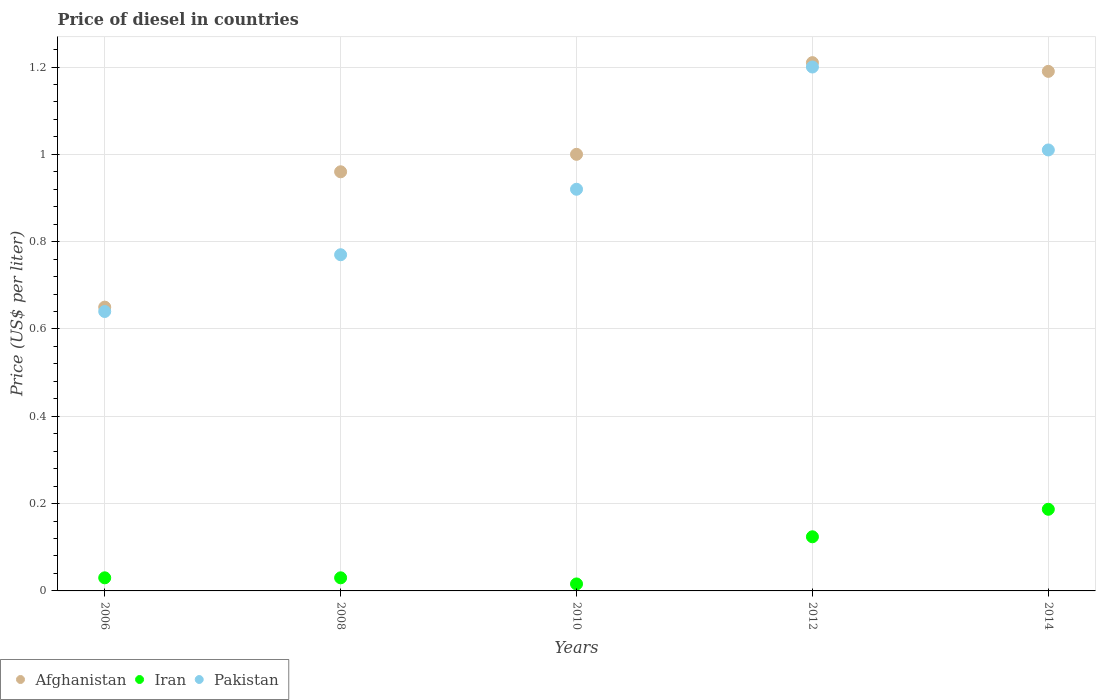How many different coloured dotlines are there?
Provide a short and direct response. 3. Is the number of dotlines equal to the number of legend labels?
Keep it short and to the point. Yes. What is the price of diesel in Afghanistan in 2010?
Make the answer very short. 1. Across all years, what is the maximum price of diesel in Afghanistan?
Offer a terse response. 1.21. Across all years, what is the minimum price of diesel in Iran?
Provide a short and direct response. 0.02. In which year was the price of diesel in Iran minimum?
Provide a succinct answer. 2010. What is the total price of diesel in Afghanistan in the graph?
Your answer should be very brief. 5.01. What is the difference between the price of diesel in Pakistan in 2006 and that in 2012?
Your answer should be compact. -0.56. What is the difference between the price of diesel in Afghanistan in 2008 and the price of diesel in Pakistan in 2012?
Offer a very short reply. -0.24. What is the average price of diesel in Iran per year?
Give a very brief answer. 0.08. In the year 2006, what is the difference between the price of diesel in Afghanistan and price of diesel in Iran?
Your response must be concise. 0.62. In how many years, is the price of diesel in Iran greater than 0.32 US$?
Ensure brevity in your answer.  0. What is the ratio of the price of diesel in Iran in 2006 to that in 2014?
Offer a very short reply. 0.16. Is the price of diesel in Pakistan in 2006 less than that in 2008?
Offer a terse response. Yes. Is the difference between the price of diesel in Afghanistan in 2006 and 2010 greater than the difference between the price of diesel in Iran in 2006 and 2010?
Offer a terse response. No. What is the difference between the highest and the second highest price of diesel in Iran?
Provide a short and direct response. 0.06. What is the difference between the highest and the lowest price of diesel in Pakistan?
Ensure brevity in your answer.  0.56. Is the sum of the price of diesel in Pakistan in 2010 and 2012 greater than the maximum price of diesel in Iran across all years?
Offer a terse response. Yes. Does the price of diesel in Pakistan monotonically increase over the years?
Keep it short and to the point. No. How many dotlines are there?
Keep it short and to the point. 3. How many years are there in the graph?
Your answer should be very brief. 5. What is the difference between two consecutive major ticks on the Y-axis?
Offer a terse response. 0.2. Are the values on the major ticks of Y-axis written in scientific E-notation?
Your answer should be very brief. No. Does the graph contain any zero values?
Give a very brief answer. No. How are the legend labels stacked?
Keep it short and to the point. Horizontal. What is the title of the graph?
Offer a very short reply. Price of diesel in countries. Does "Guinea" appear as one of the legend labels in the graph?
Keep it short and to the point. No. What is the label or title of the Y-axis?
Offer a terse response. Price (US$ per liter). What is the Price (US$ per liter) of Afghanistan in 2006?
Your response must be concise. 0.65. What is the Price (US$ per liter) of Pakistan in 2006?
Your answer should be compact. 0.64. What is the Price (US$ per liter) of Pakistan in 2008?
Provide a succinct answer. 0.77. What is the Price (US$ per liter) in Afghanistan in 2010?
Ensure brevity in your answer.  1. What is the Price (US$ per liter) of Iran in 2010?
Provide a short and direct response. 0.02. What is the Price (US$ per liter) in Pakistan in 2010?
Your answer should be compact. 0.92. What is the Price (US$ per liter) in Afghanistan in 2012?
Offer a very short reply. 1.21. What is the Price (US$ per liter) in Iran in 2012?
Offer a very short reply. 0.12. What is the Price (US$ per liter) in Pakistan in 2012?
Give a very brief answer. 1.2. What is the Price (US$ per liter) of Afghanistan in 2014?
Offer a terse response. 1.19. What is the Price (US$ per liter) of Iran in 2014?
Provide a short and direct response. 0.19. Across all years, what is the maximum Price (US$ per liter) in Afghanistan?
Keep it short and to the point. 1.21. Across all years, what is the maximum Price (US$ per liter) in Iran?
Offer a very short reply. 0.19. Across all years, what is the minimum Price (US$ per liter) in Afghanistan?
Provide a succinct answer. 0.65. Across all years, what is the minimum Price (US$ per liter) of Iran?
Keep it short and to the point. 0.02. Across all years, what is the minimum Price (US$ per liter) of Pakistan?
Your answer should be very brief. 0.64. What is the total Price (US$ per liter) in Afghanistan in the graph?
Your answer should be compact. 5.01. What is the total Price (US$ per liter) of Iran in the graph?
Provide a succinct answer. 0.39. What is the total Price (US$ per liter) of Pakistan in the graph?
Your answer should be compact. 4.54. What is the difference between the Price (US$ per liter) of Afghanistan in 2006 and that in 2008?
Provide a short and direct response. -0.31. What is the difference between the Price (US$ per liter) of Pakistan in 2006 and that in 2008?
Your answer should be very brief. -0.13. What is the difference between the Price (US$ per liter) in Afghanistan in 2006 and that in 2010?
Provide a short and direct response. -0.35. What is the difference between the Price (US$ per liter) of Iran in 2006 and that in 2010?
Keep it short and to the point. 0.01. What is the difference between the Price (US$ per liter) in Pakistan in 2006 and that in 2010?
Keep it short and to the point. -0.28. What is the difference between the Price (US$ per liter) of Afghanistan in 2006 and that in 2012?
Offer a terse response. -0.56. What is the difference between the Price (US$ per liter) in Iran in 2006 and that in 2012?
Provide a succinct answer. -0.09. What is the difference between the Price (US$ per liter) of Pakistan in 2006 and that in 2012?
Offer a terse response. -0.56. What is the difference between the Price (US$ per liter) in Afghanistan in 2006 and that in 2014?
Make the answer very short. -0.54. What is the difference between the Price (US$ per liter) in Iran in 2006 and that in 2014?
Provide a succinct answer. -0.16. What is the difference between the Price (US$ per liter) in Pakistan in 2006 and that in 2014?
Offer a very short reply. -0.37. What is the difference between the Price (US$ per liter) of Afghanistan in 2008 and that in 2010?
Offer a very short reply. -0.04. What is the difference between the Price (US$ per liter) of Iran in 2008 and that in 2010?
Ensure brevity in your answer.  0.01. What is the difference between the Price (US$ per liter) of Iran in 2008 and that in 2012?
Your response must be concise. -0.09. What is the difference between the Price (US$ per liter) in Pakistan in 2008 and that in 2012?
Offer a very short reply. -0.43. What is the difference between the Price (US$ per liter) in Afghanistan in 2008 and that in 2014?
Make the answer very short. -0.23. What is the difference between the Price (US$ per liter) of Iran in 2008 and that in 2014?
Offer a terse response. -0.16. What is the difference between the Price (US$ per liter) in Pakistan in 2008 and that in 2014?
Provide a short and direct response. -0.24. What is the difference between the Price (US$ per liter) in Afghanistan in 2010 and that in 2012?
Provide a short and direct response. -0.21. What is the difference between the Price (US$ per liter) in Iran in 2010 and that in 2012?
Your answer should be very brief. -0.11. What is the difference between the Price (US$ per liter) in Pakistan in 2010 and that in 2012?
Provide a succinct answer. -0.28. What is the difference between the Price (US$ per liter) of Afghanistan in 2010 and that in 2014?
Offer a terse response. -0.19. What is the difference between the Price (US$ per liter) in Iran in 2010 and that in 2014?
Your response must be concise. -0.17. What is the difference between the Price (US$ per liter) in Pakistan in 2010 and that in 2014?
Your answer should be very brief. -0.09. What is the difference between the Price (US$ per liter) of Afghanistan in 2012 and that in 2014?
Keep it short and to the point. 0.02. What is the difference between the Price (US$ per liter) of Iran in 2012 and that in 2014?
Your answer should be very brief. -0.06. What is the difference between the Price (US$ per liter) in Pakistan in 2012 and that in 2014?
Your response must be concise. 0.19. What is the difference between the Price (US$ per liter) in Afghanistan in 2006 and the Price (US$ per liter) in Iran in 2008?
Keep it short and to the point. 0.62. What is the difference between the Price (US$ per liter) in Afghanistan in 2006 and the Price (US$ per liter) in Pakistan in 2008?
Make the answer very short. -0.12. What is the difference between the Price (US$ per liter) in Iran in 2006 and the Price (US$ per liter) in Pakistan in 2008?
Ensure brevity in your answer.  -0.74. What is the difference between the Price (US$ per liter) of Afghanistan in 2006 and the Price (US$ per liter) of Iran in 2010?
Give a very brief answer. 0.63. What is the difference between the Price (US$ per liter) of Afghanistan in 2006 and the Price (US$ per liter) of Pakistan in 2010?
Give a very brief answer. -0.27. What is the difference between the Price (US$ per liter) in Iran in 2006 and the Price (US$ per liter) in Pakistan in 2010?
Ensure brevity in your answer.  -0.89. What is the difference between the Price (US$ per liter) in Afghanistan in 2006 and the Price (US$ per liter) in Iran in 2012?
Keep it short and to the point. 0.53. What is the difference between the Price (US$ per liter) in Afghanistan in 2006 and the Price (US$ per liter) in Pakistan in 2012?
Offer a very short reply. -0.55. What is the difference between the Price (US$ per liter) in Iran in 2006 and the Price (US$ per liter) in Pakistan in 2012?
Ensure brevity in your answer.  -1.17. What is the difference between the Price (US$ per liter) of Afghanistan in 2006 and the Price (US$ per liter) of Iran in 2014?
Your response must be concise. 0.46. What is the difference between the Price (US$ per liter) in Afghanistan in 2006 and the Price (US$ per liter) in Pakistan in 2014?
Your response must be concise. -0.36. What is the difference between the Price (US$ per liter) in Iran in 2006 and the Price (US$ per liter) in Pakistan in 2014?
Your response must be concise. -0.98. What is the difference between the Price (US$ per liter) of Afghanistan in 2008 and the Price (US$ per liter) of Iran in 2010?
Your answer should be very brief. 0.94. What is the difference between the Price (US$ per liter) in Afghanistan in 2008 and the Price (US$ per liter) in Pakistan in 2010?
Provide a succinct answer. 0.04. What is the difference between the Price (US$ per liter) of Iran in 2008 and the Price (US$ per liter) of Pakistan in 2010?
Ensure brevity in your answer.  -0.89. What is the difference between the Price (US$ per liter) in Afghanistan in 2008 and the Price (US$ per liter) in Iran in 2012?
Give a very brief answer. 0.84. What is the difference between the Price (US$ per liter) in Afghanistan in 2008 and the Price (US$ per liter) in Pakistan in 2012?
Your answer should be very brief. -0.24. What is the difference between the Price (US$ per liter) in Iran in 2008 and the Price (US$ per liter) in Pakistan in 2012?
Make the answer very short. -1.17. What is the difference between the Price (US$ per liter) of Afghanistan in 2008 and the Price (US$ per liter) of Iran in 2014?
Ensure brevity in your answer.  0.77. What is the difference between the Price (US$ per liter) in Afghanistan in 2008 and the Price (US$ per liter) in Pakistan in 2014?
Your answer should be compact. -0.05. What is the difference between the Price (US$ per liter) of Iran in 2008 and the Price (US$ per liter) of Pakistan in 2014?
Your answer should be compact. -0.98. What is the difference between the Price (US$ per liter) in Afghanistan in 2010 and the Price (US$ per liter) in Iran in 2012?
Offer a terse response. 0.88. What is the difference between the Price (US$ per liter) in Iran in 2010 and the Price (US$ per liter) in Pakistan in 2012?
Give a very brief answer. -1.18. What is the difference between the Price (US$ per liter) in Afghanistan in 2010 and the Price (US$ per liter) in Iran in 2014?
Keep it short and to the point. 0.81. What is the difference between the Price (US$ per liter) in Afghanistan in 2010 and the Price (US$ per liter) in Pakistan in 2014?
Your answer should be compact. -0.01. What is the difference between the Price (US$ per liter) of Iran in 2010 and the Price (US$ per liter) of Pakistan in 2014?
Keep it short and to the point. -0.99. What is the difference between the Price (US$ per liter) of Iran in 2012 and the Price (US$ per liter) of Pakistan in 2014?
Give a very brief answer. -0.89. What is the average Price (US$ per liter) of Iran per year?
Ensure brevity in your answer.  0.08. What is the average Price (US$ per liter) in Pakistan per year?
Offer a terse response. 0.91. In the year 2006, what is the difference between the Price (US$ per liter) in Afghanistan and Price (US$ per liter) in Iran?
Your response must be concise. 0.62. In the year 2006, what is the difference between the Price (US$ per liter) in Afghanistan and Price (US$ per liter) in Pakistan?
Keep it short and to the point. 0.01. In the year 2006, what is the difference between the Price (US$ per liter) of Iran and Price (US$ per liter) of Pakistan?
Provide a short and direct response. -0.61. In the year 2008, what is the difference between the Price (US$ per liter) in Afghanistan and Price (US$ per liter) in Pakistan?
Ensure brevity in your answer.  0.19. In the year 2008, what is the difference between the Price (US$ per liter) of Iran and Price (US$ per liter) of Pakistan?
Give a very brief answer. -0.74. In the year 2010, what is the difference between the Price (US$ per liter) in Iran and Price (US$ per liter) in Pakistan?
Offer a terse response. -0.9. In the year 2012, what is the difference between the Price (US$ per liter) in Afghanistan and Price (US$ per liter) in Iran?
Keep it short and to the point. 1.09. In the year 2012, what is the difference between the Price (US$ per liter) of Afghanistan and Price (US$ per liter) of Pakistan?
Your response must be concise. 0.01. In the year 2012, what is the difference between the Price (US$ per liter) of Iran and Price (US$ per liter) of Pakistan?
Your answer should be very brief. -1.08. In the year 2014, what is the difference between the Price (US$ per liter) of Afghanistan and Price (US$ per liter) of Pakistan?
Keep it short and to the point. 0.18. In the year 2014, what is the difference between the Price (US$ per liter) of Iran and Price (US$ per liter) of Pakistan?
Your response must be concise. -0.82. What is the ratio of the Price (US$ per liter) of Afghanistan in 2006 to that in 2008?
Give a very brief answer. 0.68. What is the ratio of the Price (US$ per liter) of Iran in 2006 to that in 2008?
Your answer should be very brief. 1. What is the ratio of the Price (US$ per liter) of Pakistan in 2006 to that in 2008?
Keep it short and to the point. 0.83. What is the ratio of the Price (US$ per liter) of Afghanistan in 2006 to that in 2010?
Offer a very short reply. 0.65. What is the ratio of the Price (US$ per liter) in Iran in 2006 to that in 2010?
Your response must be concise. 1.88. What is the ratio of the Price (US$ per liter) of Pakistan in 2006 to that in 2010?
Your answer should be very brief. 0.7. What is the ratio of the Price (US$ per liter) in Afghanistan in 2006 to that in 2012?
Keep it short and to the point. 0.54. What is the ratio of the Price (US$ per liter) of Iran in 2006 to that in 2012?
Provide a short and direct response. 0.24. What is the ratio of the Price (US$ per liter) in Pakistan in 2006 to that in 2012?
Ensure brevity in your answer.  0.53. What is the ratio of the Price (US$ per liter) in Afghanistan in 2006 to that in 2014?
Your response must be concise. 0.55. What is the ratio of the Price (US$ per liter) in Iran in 2006 to that in 2014?
Your response must be concise. 0.16. What is the ratio of the Price (US$ per liter) of Pakistan in 2006 to that in 2014?
Offer a terse response. 0.63. What is the ratio of the Price (US$ per liter) of Afghanistan in 2008 to that in 2010?
Provide a succinct answer. 0.96. What is the ratio of the Price (US$ per liter) in Iran in 2008 to that in 2010?
Your answer should be very brief. 1.88. What is the ratio of the Price (US$ per liter) in Pakistan in 2008 to that in 2010?
Provide a short and direct response. 0.84. What is the ratio of the Price (US$ per liter) in Afghanistan in 2008 to that in 2012?
Offer a very short reply. 0.79. What is the ratio of the Price (US$ per liter) of Iran in 2008 to that in 2012?
Keep it short and to the point. 0.24. What is the ratio of the Price (US$ per liter) in Pakistan in 2008 to that in 2012?
Your answer should be compact. 0.64. What is the ratio of the Price (US$ per liter) of Afghanistan in 2008 to that in 2014?
Your response must be concise. 0.81. What is the ratio of the Price (US$ per liter) in Iran in 2008 to that in 2014?
Offer a very short reply. 0.16. What is the ratio of the Price (US$ per liter) in Pakistan in 2008 to that in 2014?
Offer a terse response. 0.76. What is the ratio of the Price (US$ per liter) in Afghanistan in 2010 to that in 2012?
Your response must be concise. 0.83. What is the ratio of the Price (US$ per liter) of Iran in 2010 to that in 2012?
Keep it short and to the point. 0.13. What is the ratio of the Price (US$ per liter) of Pakistan in 2010 to that in 2012?
Provide a short and direct response. 0.77. What is the ratio of the Price (US$ per liter) in Afghanistan in 2010 to that in 2014?
Your answer should be compact. 0.84. What is the ratio of the Price (US$ per liter) of Iran in 2010 to that in 2014?
Offer a very short reply. 0.09. What is the ratio of the Price (US$ per liter) in Pakistan in 2010 to that in 2014?
Provide a succinct answer. 0.91. What is the ratio of the Price (US$ per liter) of Afghanistan in 2012 to that in 2014?
Give a very brief answer. 1.02. What is the ratio of the Price (US$ per liter) of Iran in 2012 to that in 2014?
Make the answer very short. 0.66. What is the ratio of the Price (US$ per liter) in Pakistan in 2012 to that in 2014?
Ensure brevity in your answer.  1.19. What is the difference between the highest and the second highest Price (US$ per liter) in Afghanistan?
Your answer should be very brief. 0.02. What is the difference between the highest and the second highest Price (US$ per liter) in Iran?
Your response must be concise. 0.06. What is the difference between the highest and the second highest Price (US$ per liter) of Pakistan?
Provide a succinct answer. 0.19. What is the difference between the highest and the lowest Price (US$ per liter) of Afghanistan?
Ensure brevity in your answer.  0.56. What is the difference between the highest and the lowest Price (US$ per liter) of Iran?
Give a very brief answer. 0.17. What is the difference between the highest and the lowest Price (US$ per liter) in Pakistan?
Provide a succinct answer. 0.56. 